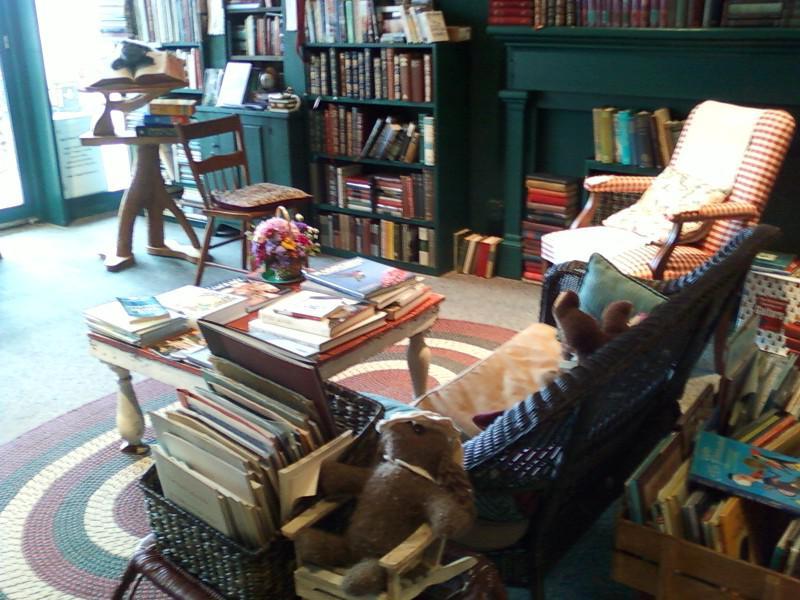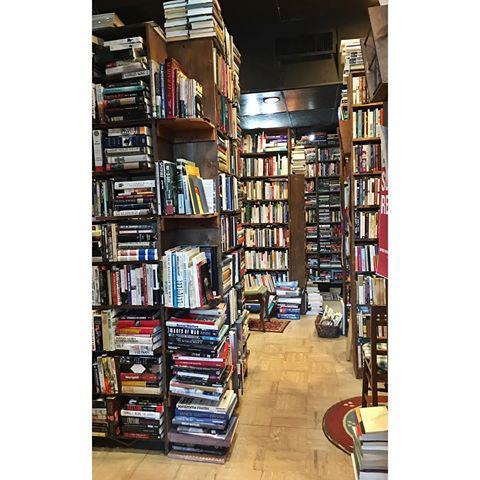The first image is the image on the left, the second image is the image on the right. Evaluate the accuracy of this statement regarding the images: "In one of the images, people are actively browsing the books.". Is it true? Answer yes or no. No. The first image is the image on the left, the second image is the image on the right. Examine the images to the left and right. Is the description "One image contains more than thirty books and more than two people." accurate? Answer yes or no. No. 